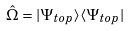Convert formula to latex. <formula><loc_0><loc_0><loc_500><loc_500>\hat { \Omega } = | \Psi _ { t o p } \rangle \langle \Psi _ { t o p } |</formula> 